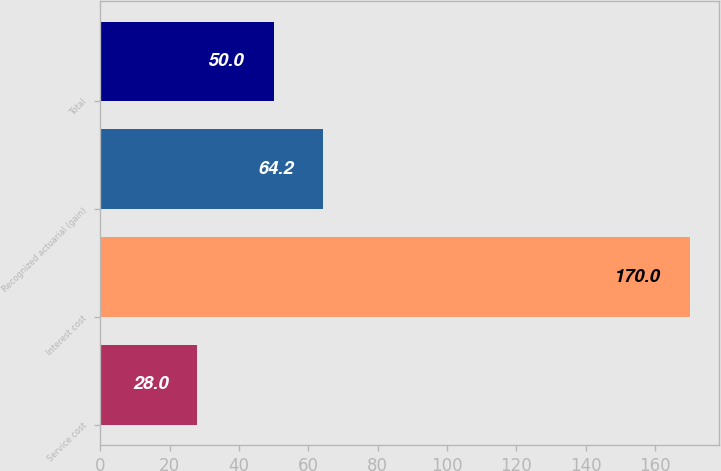Convert chart. <chart><loc_0><loc_0><loc_500><loc_500><bar_chart><fcel>Service cost<fcel>Interest cost<fcel>Recognized actuarial (gain)<fcel>Total<nl><fcel>28<fcel>170<fcel>64.2<fcel>50<nl></chart> 